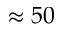Convert formula to latex. <formula><loc_0><loc_0><loc_500><loc_500>\approx 5 0</formula> 